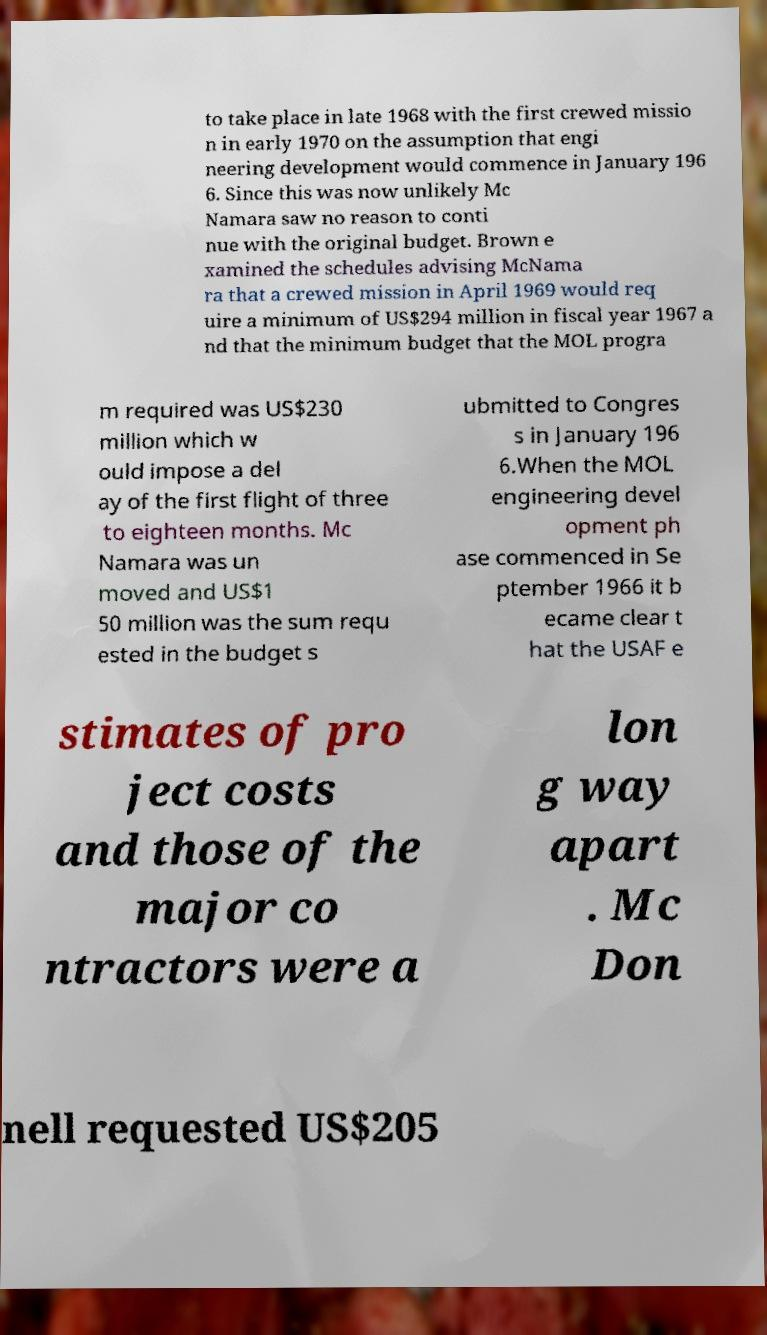Could you extract and type out the text from this image? to take place in late 1968 with the first crewed missio n in early 1970 on the assumption that engi neering development would commence in January 196 6. Since this was now unlikely Mc Namara saw no reason to conti nue with the original budget. Brown e xamined the schedules advising McNama ra that a crewed mission in April 1969 would req uire a minimum of US$294 million in fiscal year 1967 a nd that the minimum budget that the MOL progra m required was US$230 million which w ould impose a del ay of the first flight of three to eighteen months. Mc Namara was un moved and US$1 50 million was the sum requ ested in the budget s ubmitted to Congres s in January 196 6.When the MOL engineering devel opment ph ase commenced in Se ptember 1966 it b ecame clear t hat the USAF e stimates of pro ject costs and those of the major co ntractors were a lon g way apart . Mc Don nell requested US$205 